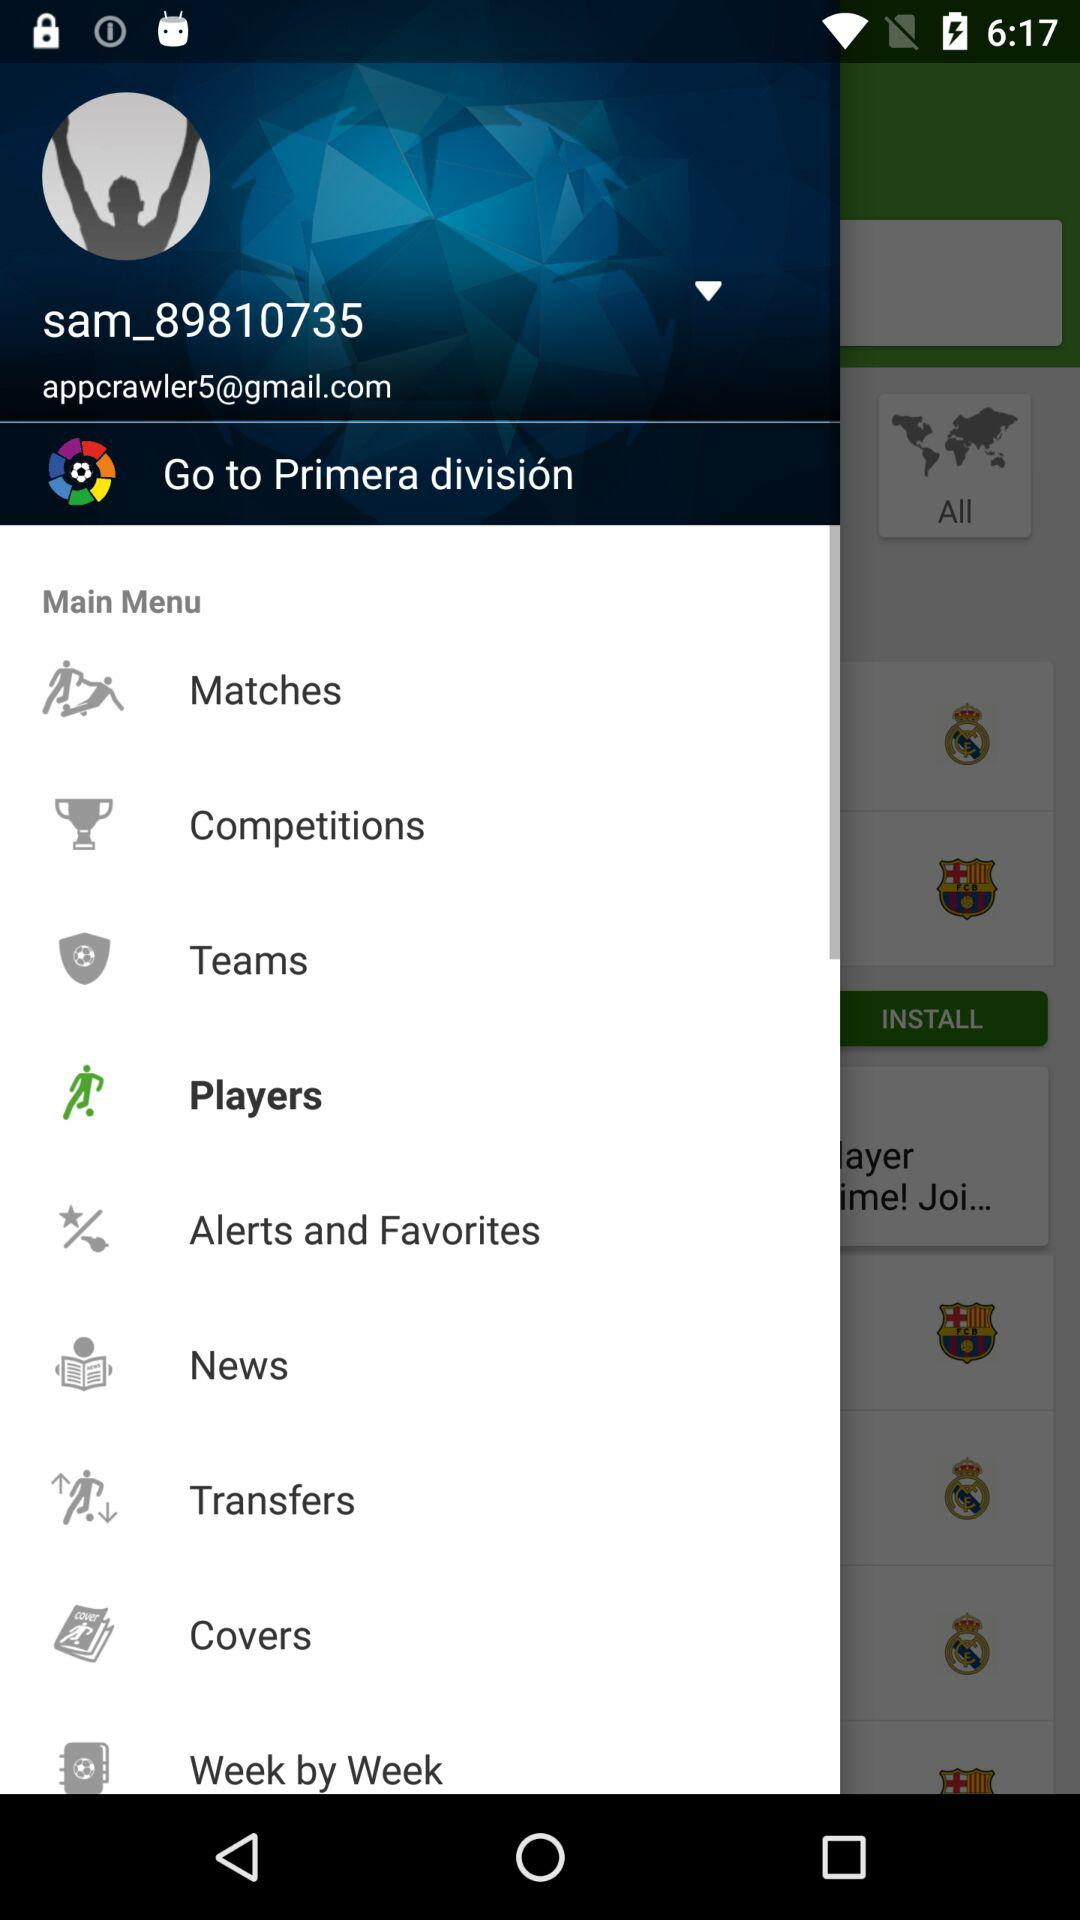What is the email address shown on the app? The email address is appcrawler5@gmail.com. 